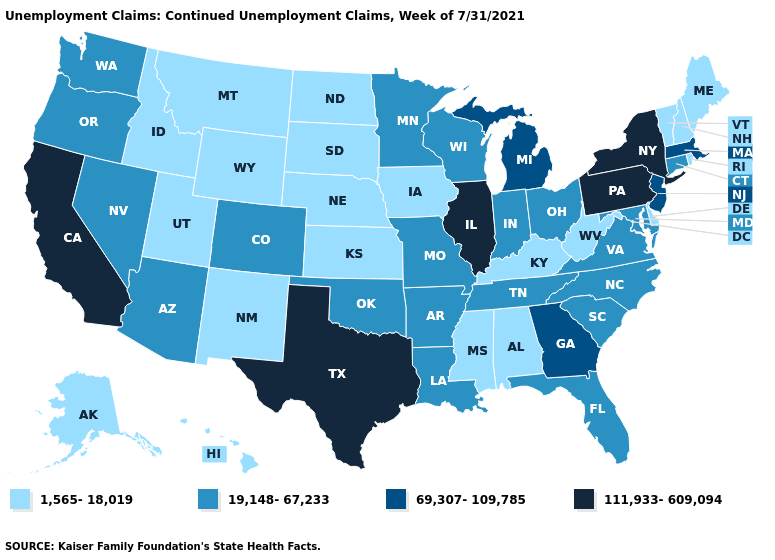What is the value of Louisiana?
Be succinct. 19,148-67,233. Which states have the highest value in the USA?
Give a very brief answer. California, Illinois, New York, Pennsylvania, Texas. Among the states that border Mississippi , does Alabama have the lowest value?
Be succinct. Yes. Does the map have missing data?
Concise answer only. No. Does the map have missing data?
Concise answer only. No. What is the value of New Mexico?
Give a very brief answer. 1,565-18,019. Is the legend a continuous bar?
Answer briefly. No. Among the states that border Delaware , does Pennsylvania have the highest value?
Quick response, please. Yes. Does Nebraska have the lowest value in the USA?
Write a very short answer. Yes. What is the highest value in the USA?
Be succinct. 111,933-609,094. What is the lowest value in the MidWest?
Short answer required. 1,565-18,019. Name the states that have a value in the range 111,933-609,094?
Keep it brief. California, Illinois, New York, Pennsylvania, Texas. Does the first symbol in the legend represent the smallest category?
Quick response, please. Yes. What is the highest value in states that border California?
Be succinct. 19,148-67,233. Which states have the lowest value in the USA?
Write a very short answer. Alabama, Alaska, Delaware, Hawaii, Idaho, Iowa, Kansas, Kentucky, Maine, Mississippi, Montana, Nebraska, New Hampshire, New Mexico, North Dakota, Rhode Island, South Dakota, Utah, Vermont, West Virginia, Wyoming. 